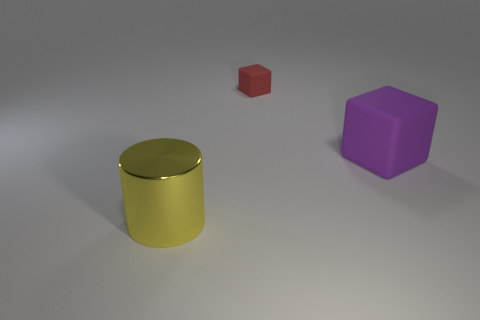Add 2 tiny purple things. How many objects exist? 5 Subtract all red cubes. How many cubes are left? 1 Subtract all cylinders. How many objects are left? 2 Subtract 0 green cylinders. How many objects are left? 3 Subtract all rubber blocks. Subtract all big yellow balls. How many objects are left? 1 Add 2 big yellow cylinders. How many big yellow cylinders are left? 3 Add 1 big blocks. How many big blocks exist? 2 